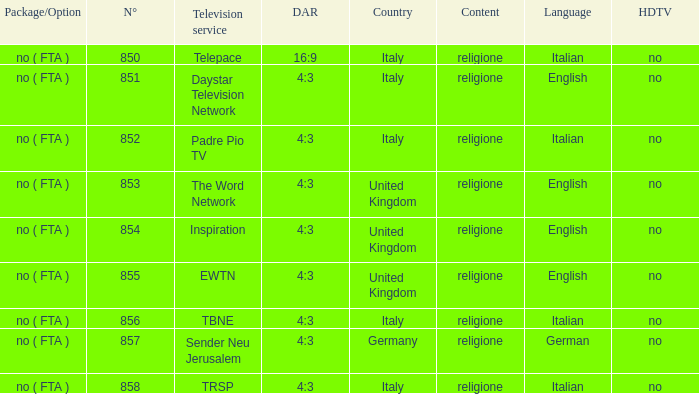How many dar are in germany? 4:3. 